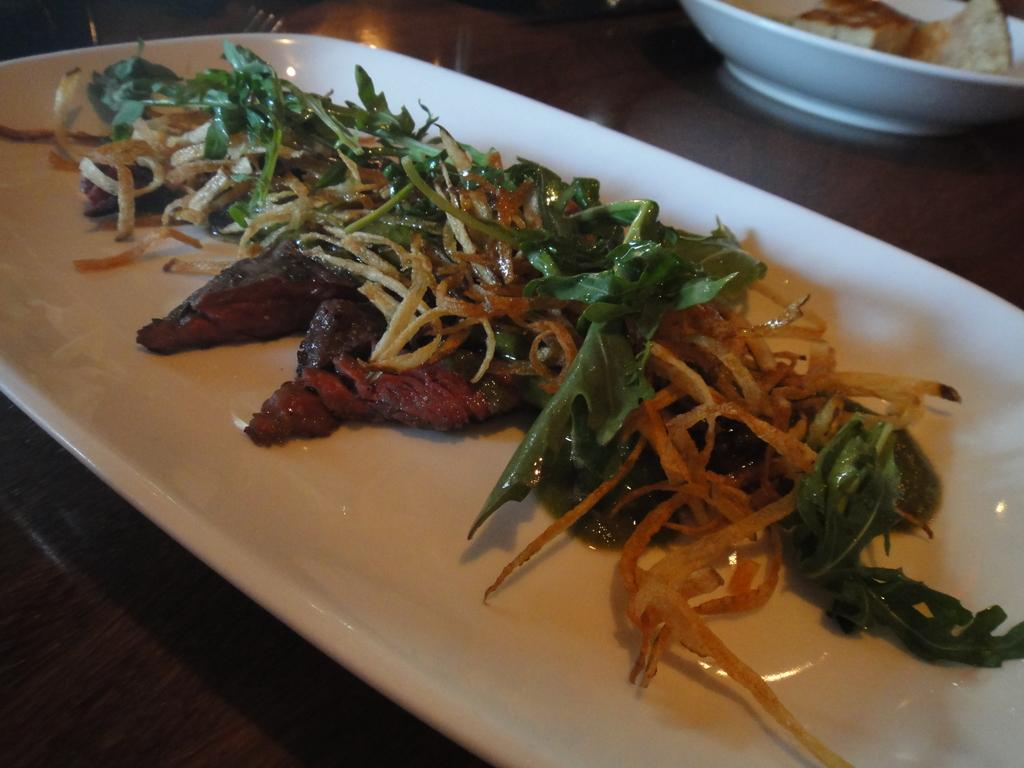What type of dishware is used to serve food in the image? There is a serving plate and a serving bowl used to serve food in the image. Where are the serving plate and bowl located? The serving plate and bowl are placed on a table. How many types of dishware are used to serve food in the image? There are used to serve food in the image. Can you see any goldfish swimming in the serving plate in the image? No, there are no goldfish present in the image, and they are not swimming in the serving plate. Is there a hen laying eggs on the table in the image? No, there is no hen or eggs present in the image. 